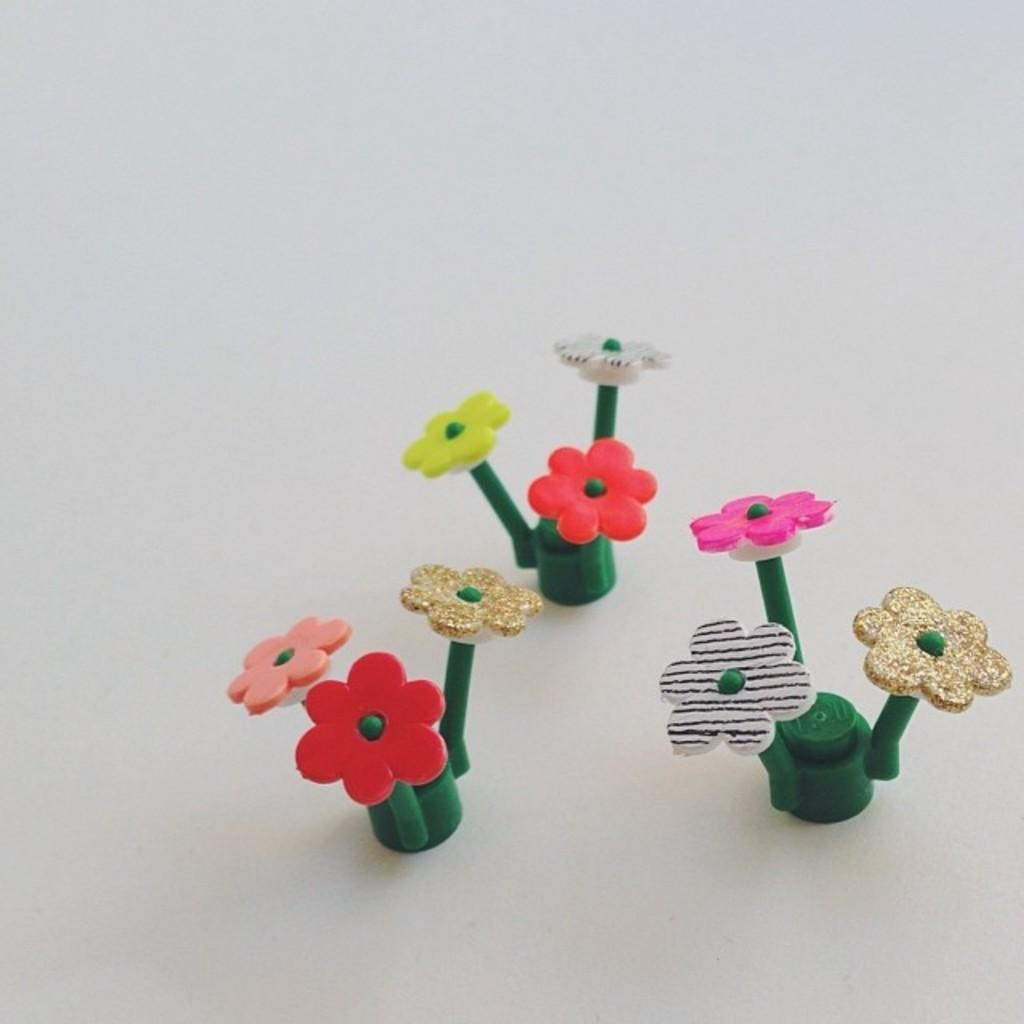What type of flowers are present in the image? The flowers in the image are artificial flowers. Where are the artificial flowers located? The artificial flowers are on a surface. How many beans are visible in the image? There are no beans present in the image; it features artificial flowers on a surface. 